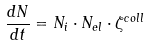Convert formula to latex. <formula><loc_0><loc_0><loc_500><loc_500>\frac { d N } { d t } = N _ { i } \cdot N _ { e l } \cdot \zeta ^ { c o l l }</formula> 